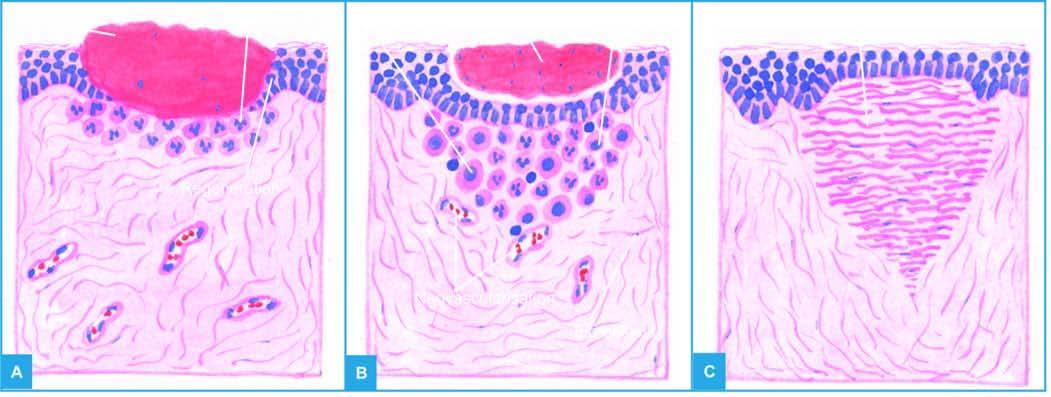s the wedge-shaped infarct left after contraction of the wound?
Answer the question using a single word or phrase. No 